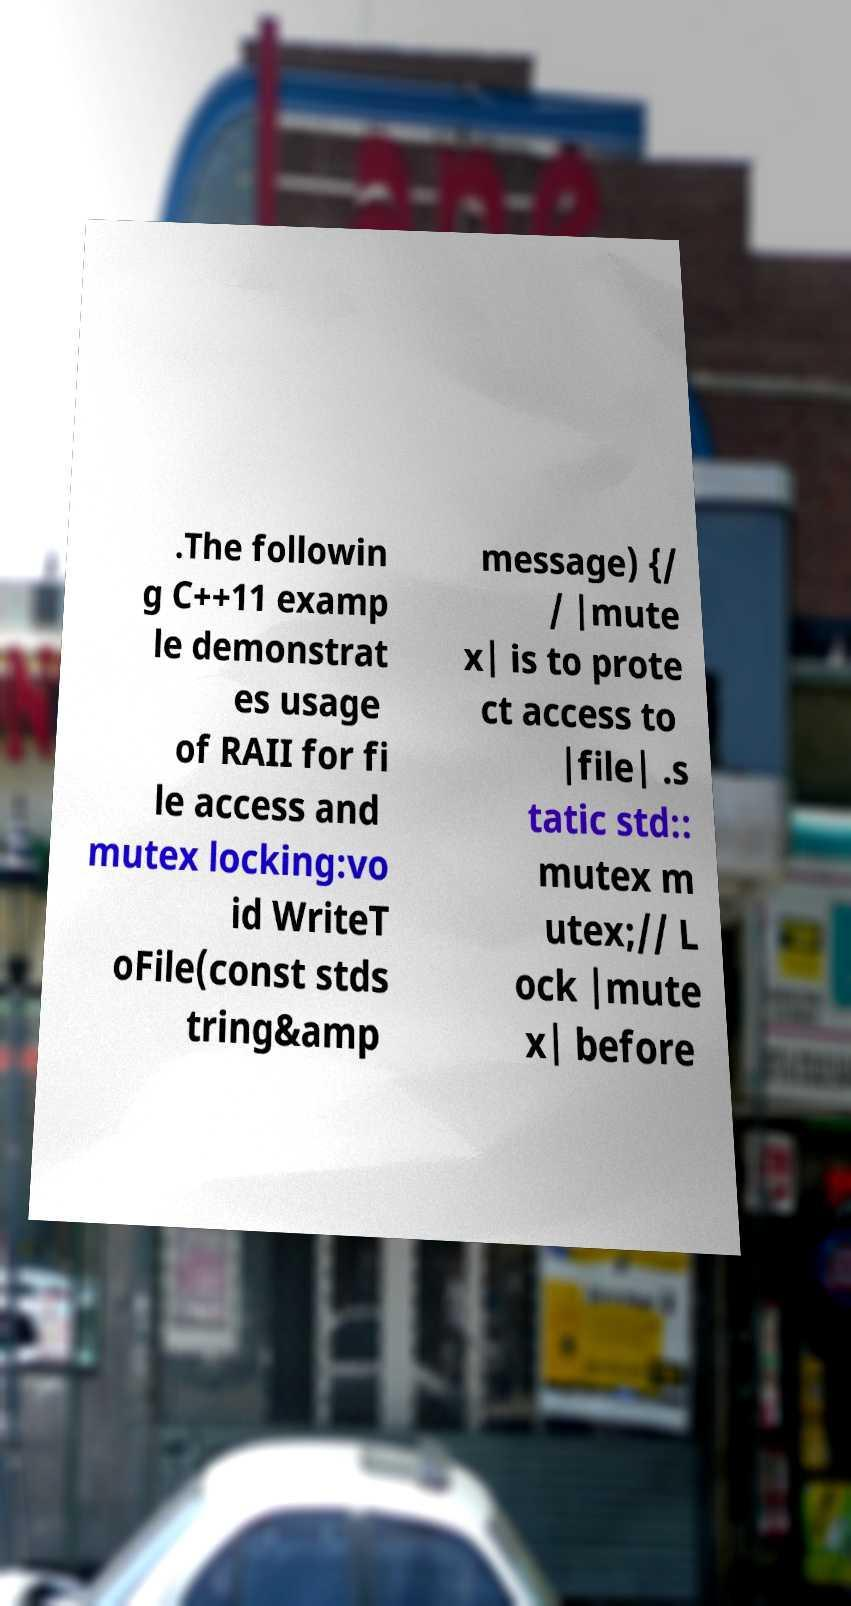Can you accurately transcribe the text from the provided image for me? .The followin g C++11 examp le demonstrat es usage of RAII for fi le access and mutex locking:vo id WriteT oFile(const stds tring&amp message) {/ / |mute x| is to prote ct access to |file| .s tatic std:: mutex m utex;// L ock |mute x| before 